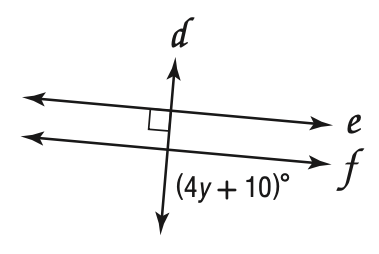Question: Find y so that e \parallel f.
Choices:
A. 20
B. 25
C. 80
D. 90
Answer with the letter. Answer: A 